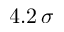<formula> <loc_0><loc_0><loc_500><loc_500>4 . 2 \, \sigma</formula> 